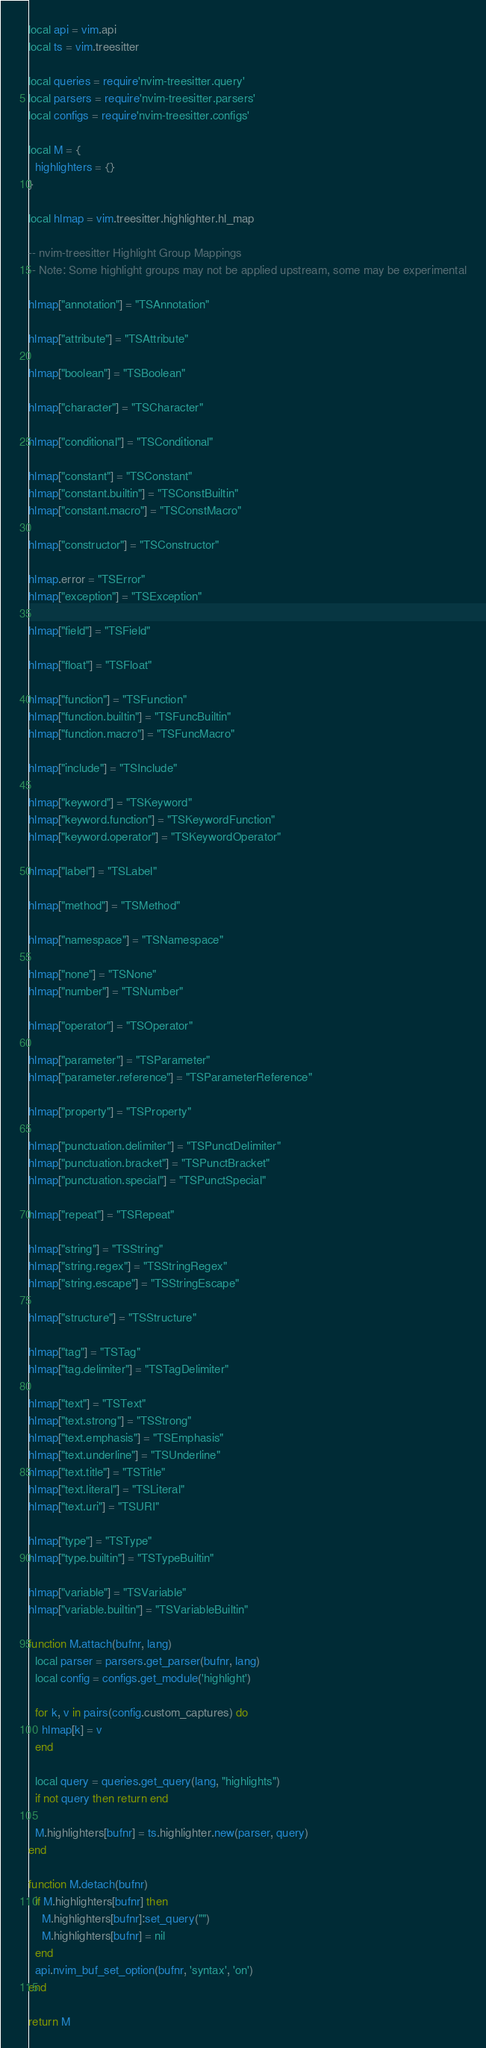Convert code to text. <code><loc_0><loc_0><loc_500><loc_500><_Lua_>local api = vim.api
local ts = vim.treesitter

local queries = require'nvim-treesitter.query'
local parsers = require'nvim-treesitter.parsers'
local configs = require'nvim-treesitter.configs'

local M = {
  highlighters = {}
}

local hlmap = vim.treesitter.highlighter.hl_map

-- nvim-treesitter Highlight Group Mappings
-- Note: Some highlight groups may not be applied upstream, some may be experimental

hlmap["annotation"] = "TSAnnotation"

hlmap["attribute"] = "TSAttribute"

hlmap["boolean"] = "TSBoolean"

hlmap["character"] = "TSCharacter"

hlmap["conditional"] = "TSConditional"

hlmap["constant"] = "TSConstant"
hlmap["constant.builtin"] = "TSConstBuiltin"
hlmap["constant.macro"] = "TSConstMacro"

hlmap["constructor"] = "TSConstructor"

hlmap.error = "TSError"
hlmap["exception"] = "TSException"

hlmap["field"] = "TSField"

hlmap["float"] = "TSFloat"

hlmap["function"] = "TSFunction"
hlmap["function.builtin"] = "TSFuncBuiltin"
hlmap["function.macro"] = "TSFuncMacro"

hlmap["include"] = "TSInclude"

hlmap["keyword"] = "TSKeyword"
hlmap["keyword.function"] = "TSKeywordFunction"
hlmap["keyword.operator"] = "TSKeywordOperator"

hlmap["label"] = "TSLabel"

hlmap["method"] = "TSMethod"

hlmap["namespace"] = "TSNamespace"

hlmap["none"] = "TSNone"
hlmap["number"] = "TSNumber"

hlmap["operator"] = "TSOperator"

hlmap["parameter"] = "TSParameter"
hlmap["parameter.reference"] = "TSParameterReference"

hlmap["property"] = "TSProperty"

hlmap["punctuation.delimiter"] = "TSPunctDelimiter"
hlmap["punctuation.bracket"] = "TSPunctBracket"
hlmap["punctuation.special"] = "TSPunctSpecial"

hlmap["repeat"] = "TSRepeat"

hlmap["string"] = "TSString"
hlmap["string.regex"] = "TSStringRegex"
hlmap["string.escape"] = "TSStringEscape"

hlmap["structure"] = "TSStructure"

hlmap["tag"] = "TSTag"
hlmap["tag.delimiter"] = "TSTagDelimiter"

hlmap["text"] = "TSText"
hlmap["text.strong"] = "TSStrong"
hlmap["text.emphasis"] = "TSEmphasis"
hlmap["text.underline"] = "TSUnderline"
hlmap["text.title"] = "TSTitle"
hlmap["text.literal"] = "TSLiteral"
hlmap["text.uri"] = "TSURI"

hlmap["type"] = "TSType"
hlmap["type.builtin"] = "TSTypeBuiltin"

hlmap["variable"] = "TSVariable"
hlmap["variable.builtin"] = "TSVariableBuiltin"

function M.attach(bufnr, lang)
  local parser = parsers.get_parser(bufnr, lang)
  local config = configs.get_module('highlight')

  for k, v in pairs(config.custom_captures) do
    hlmap[k] = v
  end

  local query = queries.get_query(lang, "highlights")
  if not query then return end

  M.highlighters[bufnr] = ts.highlighter.new(parser, query)
end

function M.detach(bufnr)
  if M.highlighters[bufnr] then
    M.highlighters[bufnr]:set_query("")
    M.highlighters[bufnr] = nil
  end
  api.nvim_buf_set_option(bufnr, 'syntax', 'on')
end

return M
</code> 